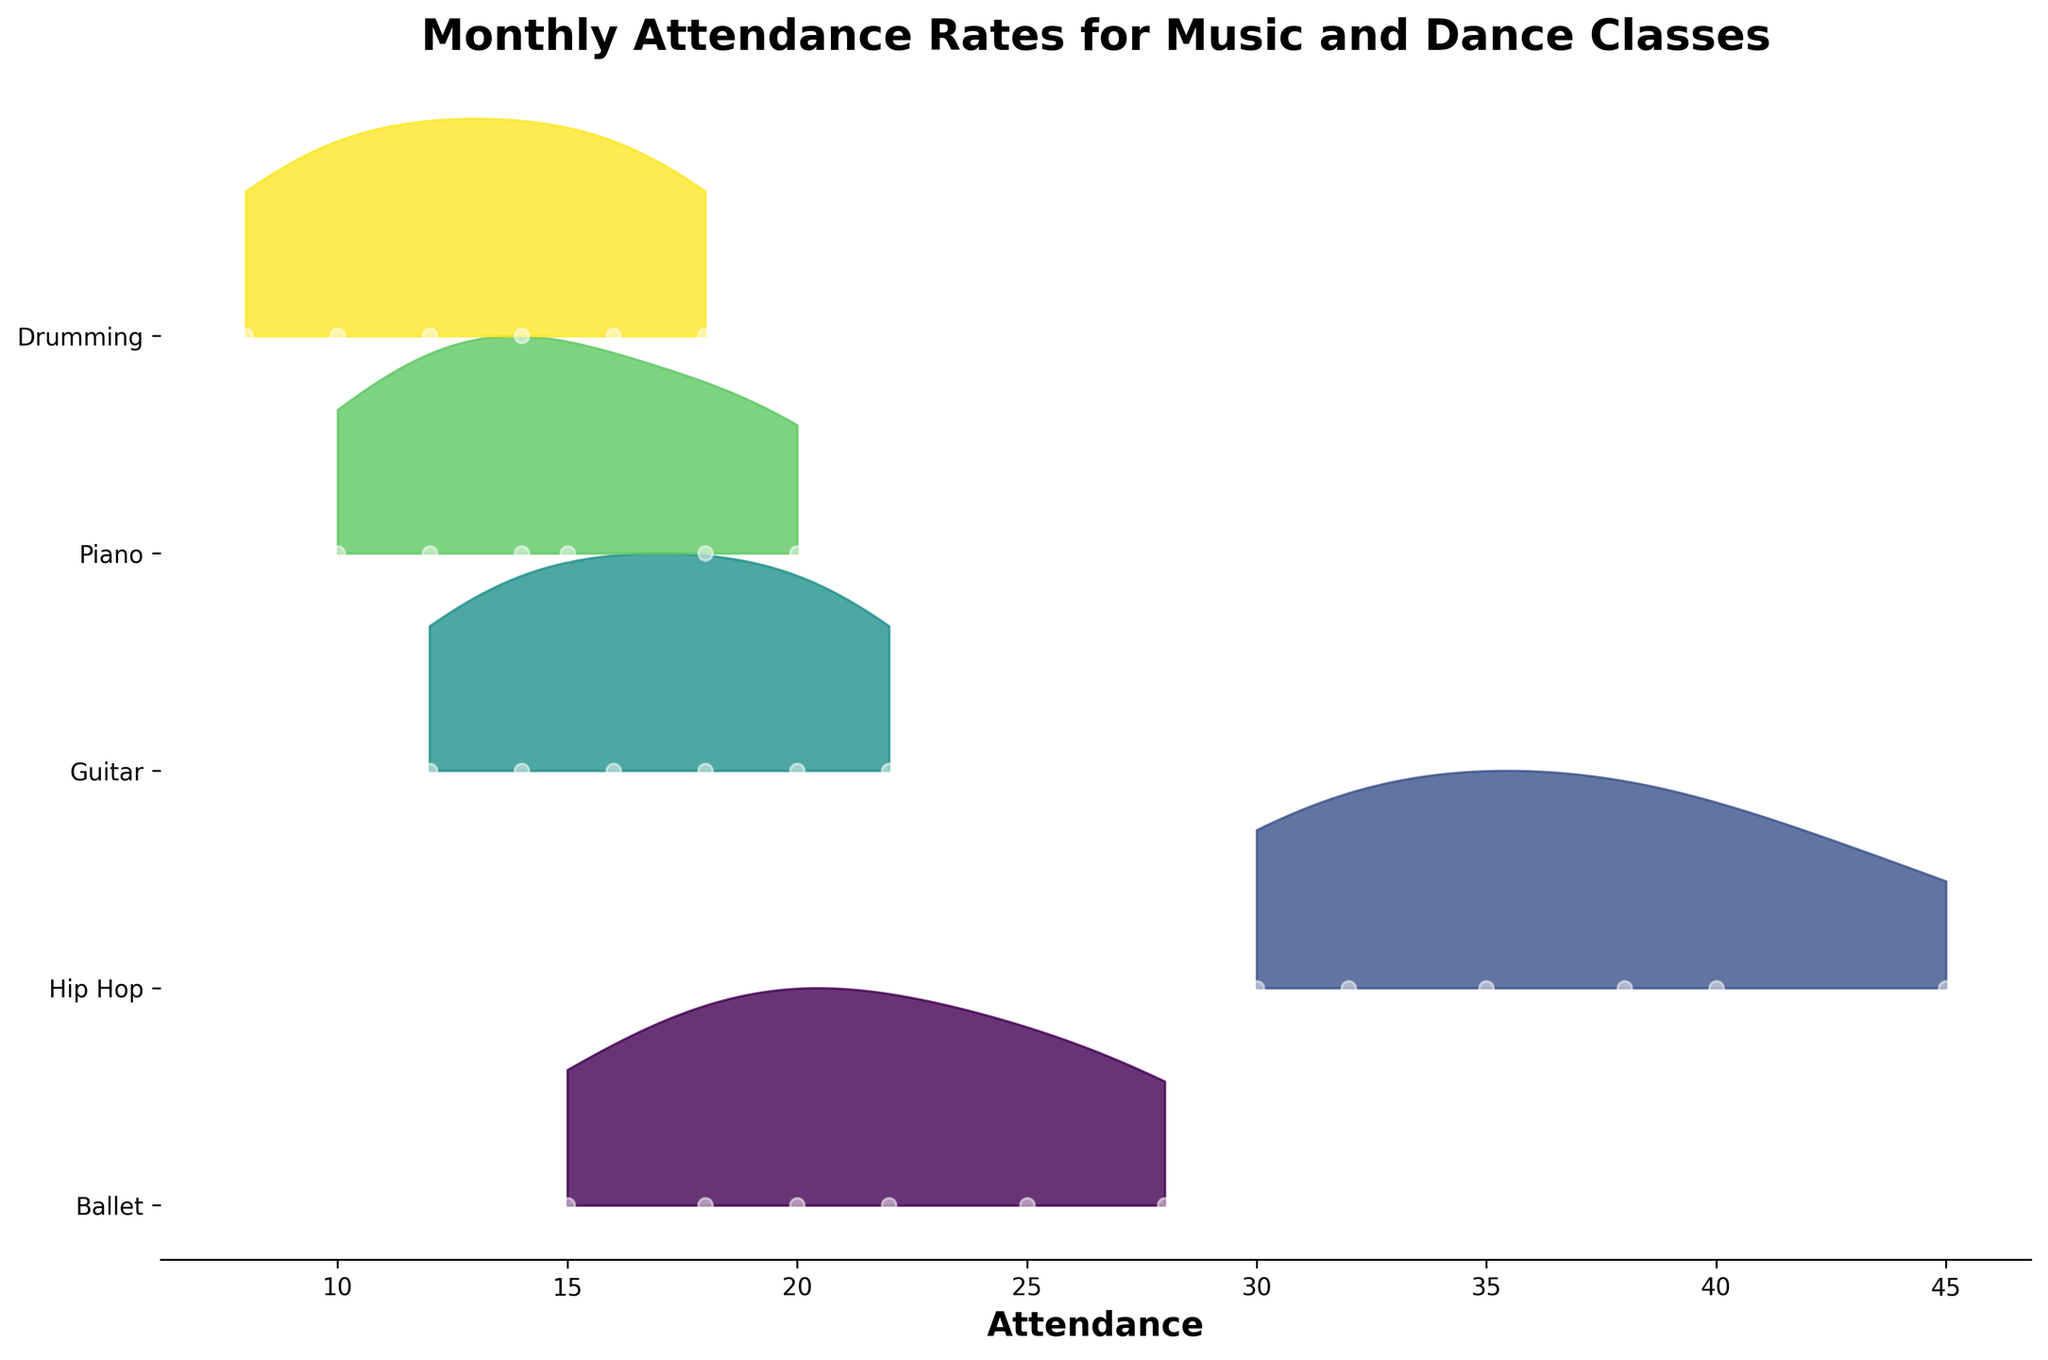Which class has the highest average attendance across all months? To determine the highest average attendance, first calculate the average for each class: Ballet (21.3), Hip Hop (36.7), Guitar (17), Piano (14.8), and Drumming (13). Hip Hop has the highest average attendance.
Answer: Hip Hop Which month saw the highest attendance for Hip Hop? Look at the attendance values for Hip Hop across January to June: 30, 32, 35, 38, 40, 45. The highest attendance is in June.
Answer: June Which class shows the largest increase in attendance from January to June? Calculate the increase for each class: Ballet (13), Hip Hop (15), Guitar (10), Piano (10), Drumming (10). Hip Hop shows the largest increase.
Answer: Hip Hop How does the attendance of Guitar in March compare to the attendance of Piano in April? The attendance for Guitar in March is 16 and for Piano in April is 14. Guitar in March has higher attendance than Piano in April.
Answer: Guitar in March Which class has the most consistent (least variable) attendance from January to June? Evaluate the spread/variation: Ballet (13), Hip Hop (15), Guitar (10), Piano (10), Drumming (10). Guitar, Piano, and Drumming have the least variable attendance with a spread of 10 each.
Answer: Guitar, Piano, Drumming What's the main trend observed across all classes from January to June? For each class, the attendance tends to increase over the months from January to June, indicating a general upward trend in attendance.
Answer: General upward trend Is there any class where the attendance remained constant between any two consecutive months? Look at the data for any class where the attendance does not change between months. All classes have changing attendance values in the consecutive months.
Answer: None Between Ballet and Drumming, which class had higher attendance in May? The attendance in May for Ballet is 25 and for Drumming is 16. Ballet had higher attendance in May.
Answer: Ballet 